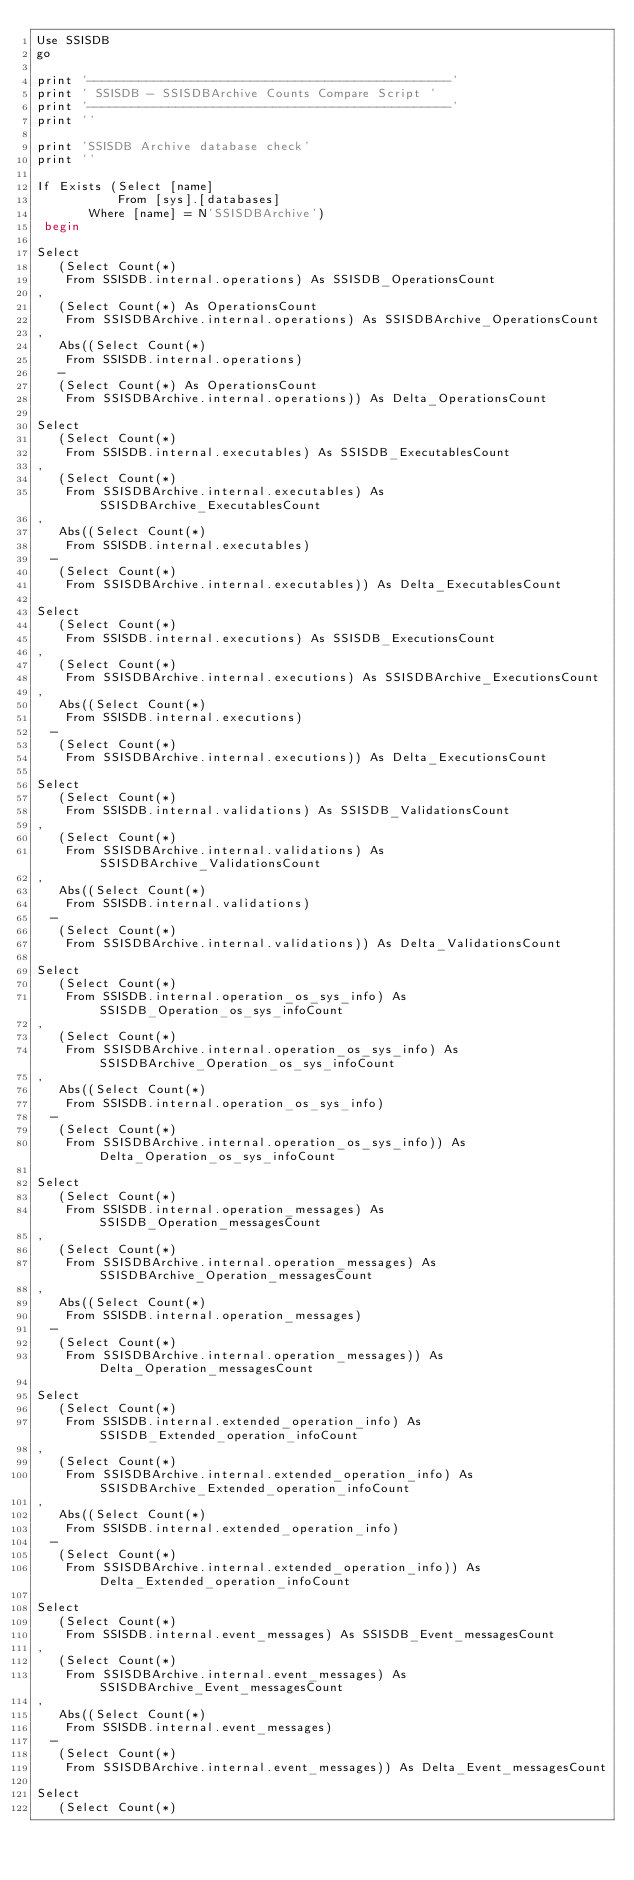<code> <loc_0><loc_0><loc_500><loc_500><_SQL_>Use SSISDB
go

print '-------------------------------------------------'
print ' SSISDB - SSISDBArchive Counts Compare Script '
print '-------------------------------------------------'
print ''

print 'SSISDB Archive database check'
print ''

If Exists (Select [name]
           From [sys].[databases]
		   Where [name] = N'SSISDBArchive')
 begin

Select
   (Select Count(*)
    From SSISDB.internal.operations) As SSISDB_OperationsCount
,
   (Select Count(*) As OperationsCount
    From SSISDBArchive.internal.operations) As SSISDBArchive_OperationsCount
,
   Abs((Select Count(*)
    From SSISDB.internal.operations)
   -
   (Select Count(*) As OperationsCount
    From SSISDBArchive.internal.operations)) As Delta_OperationsCount

Select
   (Select Count(*)
    From SSISDB.internal.executables) As SSISDB_ExecutablesCount
,
   (Select Count(*)
    From SSISDBArchive.internal.executables) As SSISDBArchive_ExecutablesCount
,
   Abs((Select Count(*)
    From SSISDB.internal.executables)
	-
   (Select Count(*)
    From SSISDBArchive.internal.executables)) As Delta_ExecutablesCount

Select
   (Select Count(*)
    From SSISDB.internal.executions) As SSISDB_ExecutionsCount
,
   (Select Count(*)
    From SSISDBArchive.internal.executions) As SSISDBArchive_ExecutionsCount
,
   Abs((Select Count(*)
    From SSISDB.internal.executions)
	-
   (Select Count(*)
    From SSISDBArchive.internal.executions)) As Delta_ExecutionsCount

Select
   (Select Count(*)
    From SSISDB.internal.validations) As SSISDB_ValidationsCount
,
   (Select Count(*)
    From SSISDBArchive.internal.validations) As SSISDBArchive_ValidationsCount
,
   Abs((Select Count(*)
    From SSISDB.internal.validations)
	-
   (Select Count(*)
    From SSISDBArchive.internal.validations)) As Delta_ValidationsCount

Select
   (Select Count(*)
    From SSISDB.internal.operation_os_sys_info) As SSISDB_Operation_os_sys_infoCount
,
   (Select Count(*)
    From SSISDBArchive.internal.operation_os_sys_info) As SSISDBArchive_Operation_os_sys_infoCount
,
   Abs((Select Count(*)
    From SSISDB.internal.operation_os_sys_info)
	-
   (Select Count(*)
    From SSISDBArchive.internal.operation_os_sys_info)) As Delta_Operation_os_sys_infoCount

Select
   (Select Count(*)
    From SSISDB.internal.operation_messages) As SSISDB_Operation_messagesCount
,
   (Select Count(*)
    From SSISDBArchive.internal.operation_messages) As SSISDBArchive_Operation_messagesCount
,
   Abs((Select Count(*)
    From SSISDB.internal.operation_messages)
	-
   (Select Count(*)
    From SSISDBArchive.internal.operation_messages)) As Delta_Operation_messagesCount

Select
   (Select Count(*)
    From SSISDB.internal.extended_operation_info) As SSISDB_Extended_operation_infoCount
,
   (Select Count(*)
    From SSISDBArchive.internal.extended_operation_info) As SSISDBArchive_Extended_operation_infoCount
,
   Abs((Select Count(*)
    From SSISDB.internal.extended_operation_info)
	-
   (Select Count(*)
    From SSISDBArchive.internal.extended_operation_info)) As Delta_Extended_operation_infoCount

Select
   (Select Count(*)
    From SSISDB.internal.event_messages) As SSISDB_Event_messagesCount
,
   (Select Count(*)
    From SSISDBArchive.internal.event_messages) As SSISDBArchive_Event_messagesCount
,
   Abs((Select Count(*)
    From SSISDB.internal.event_messages)
	-
   (Select Count(*)
    From SSISDBArchive.internal.event_messages)) As Delta_Event_messagesCount

Select
   (Select Count(*)</code> 